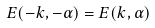Convert formula to latex. <formula><loc_0><loc_0><loc_500><loc_500>E ( - k , - \alpha ) = E ( k , \alpha )</formula> 